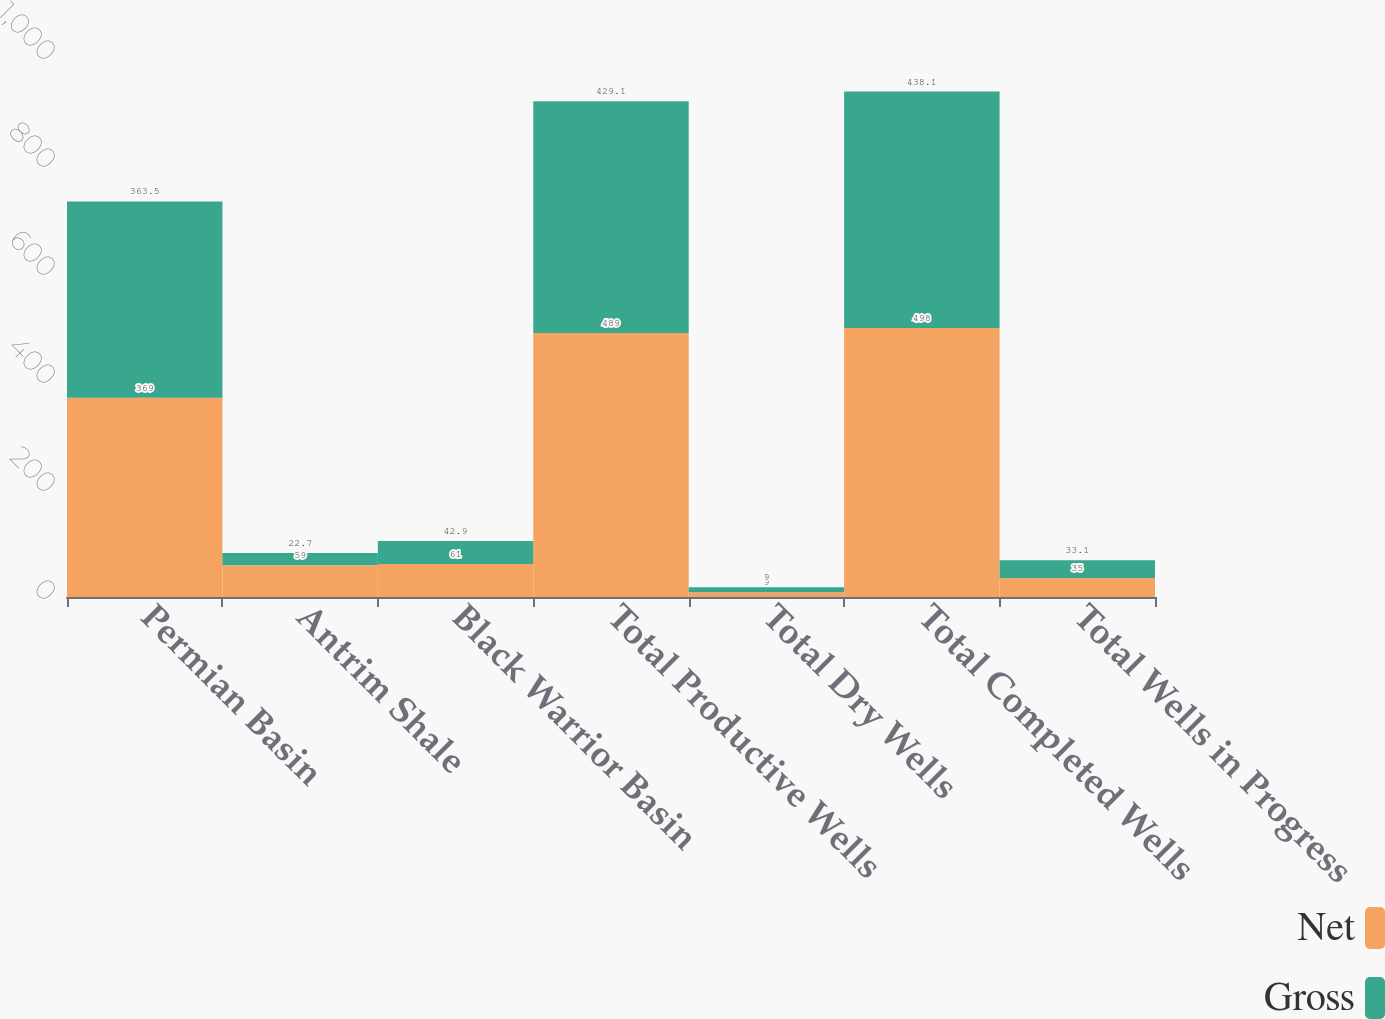<chart> <loc_0><loc_0><loc_500><loc_500><stacked_bar_chart><ecel><fcel>Permian Basin<fcel>Antrim Shale<fcel>Black Warrior Basin<fcel>Total Productive Wells<fcel>Total Dry Wells<fcel>Total Completed Wells<fcel>Total Wells in Progress<nl><fcel>Net<fcel>369<fcel>59<fcel>61<fcel>489<fcel>9<fcel>498<fcel>35<nl><fcel>Gross<fcel>363.5<fcel>22.7<fcel>42.9<fcel>429.1<fcel>9<fcel>438.1<fcel>33.1<nl></chart> 